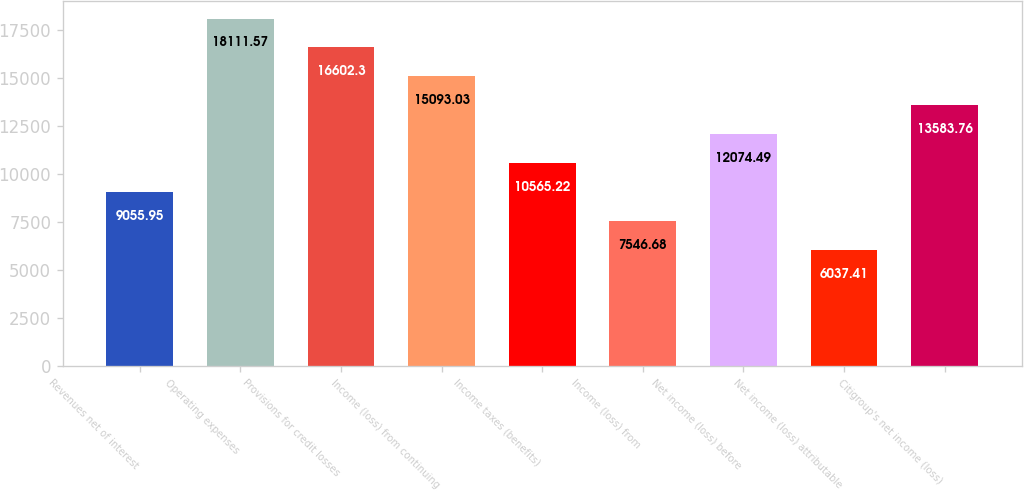Convert chart to OTSL. <chart><loc_0><loc_0><loc_500><loc_500><bar_chart><fcel>Revenues net of interest<fcel>Operating expenses<fcel>Provisions for credit losses<fcel>Income (loss) from continuing<fcel>Income taxes (benefits)<fcel>Income (loss) from<fcel>Net income (loss) before<fcel>Net income (loss) attributable<fcel>Citigroup's net income (loss)<nl><fcel>9055.95<fcel>18111.6<fcel>16602.3<fcel>15093<fcel>10565.2<fcel>7546.68<fcel>12074.5<fcel>6037.41<fcel>13583.8<nl></chart> 